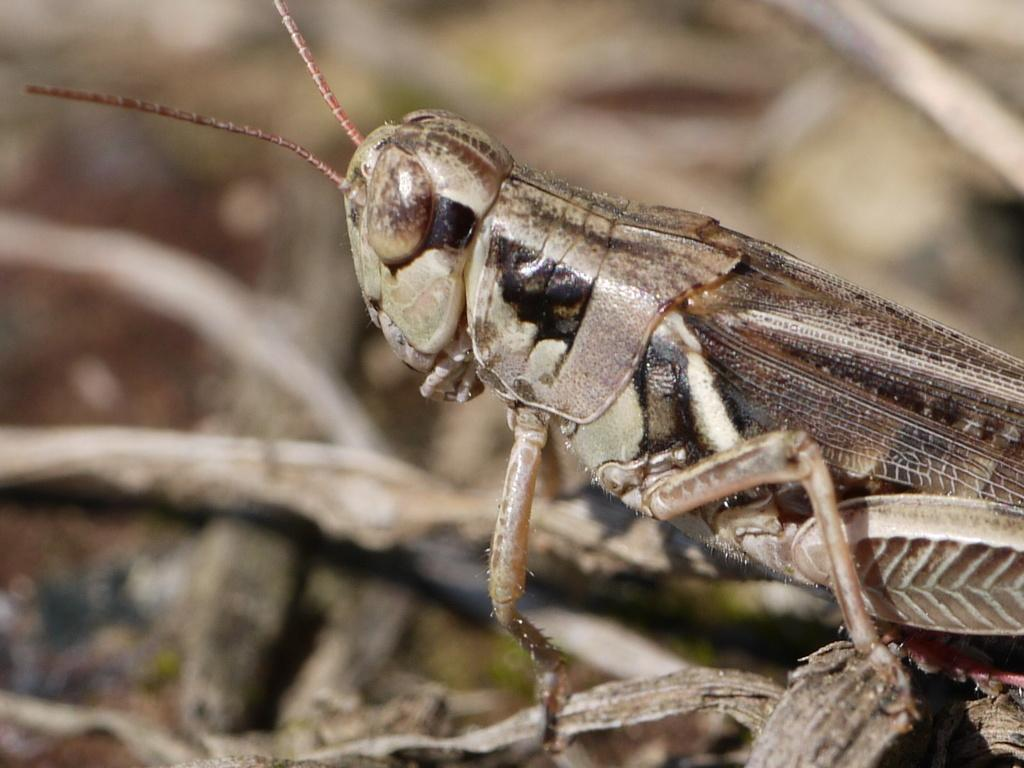What type of creature can be seen in the image? There is an insect in the image. How much money is the insect holding in the image? There is no indication of money or any financial transaction in the image, as it features an insect. 